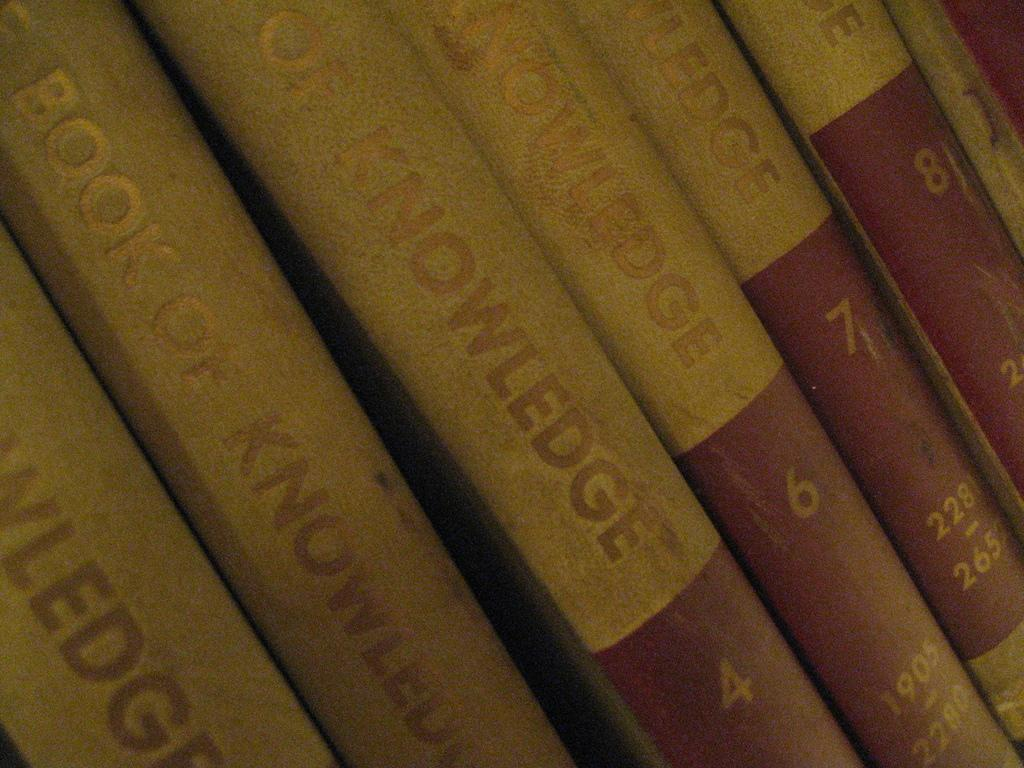<image>
Offer a succinct explanation of the picture presented. A row of Book of Knowledge encyclopedias, numbers two through eight. 